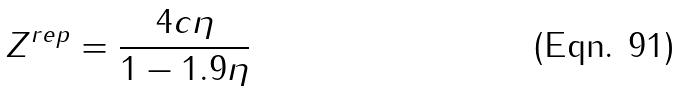<formula> <loc_0><loc_0><loc_500><loc_500>Z ^ { r e p } = \frac { 4 c \eta } { 1 - 1 . 9 \eta }</formula> 